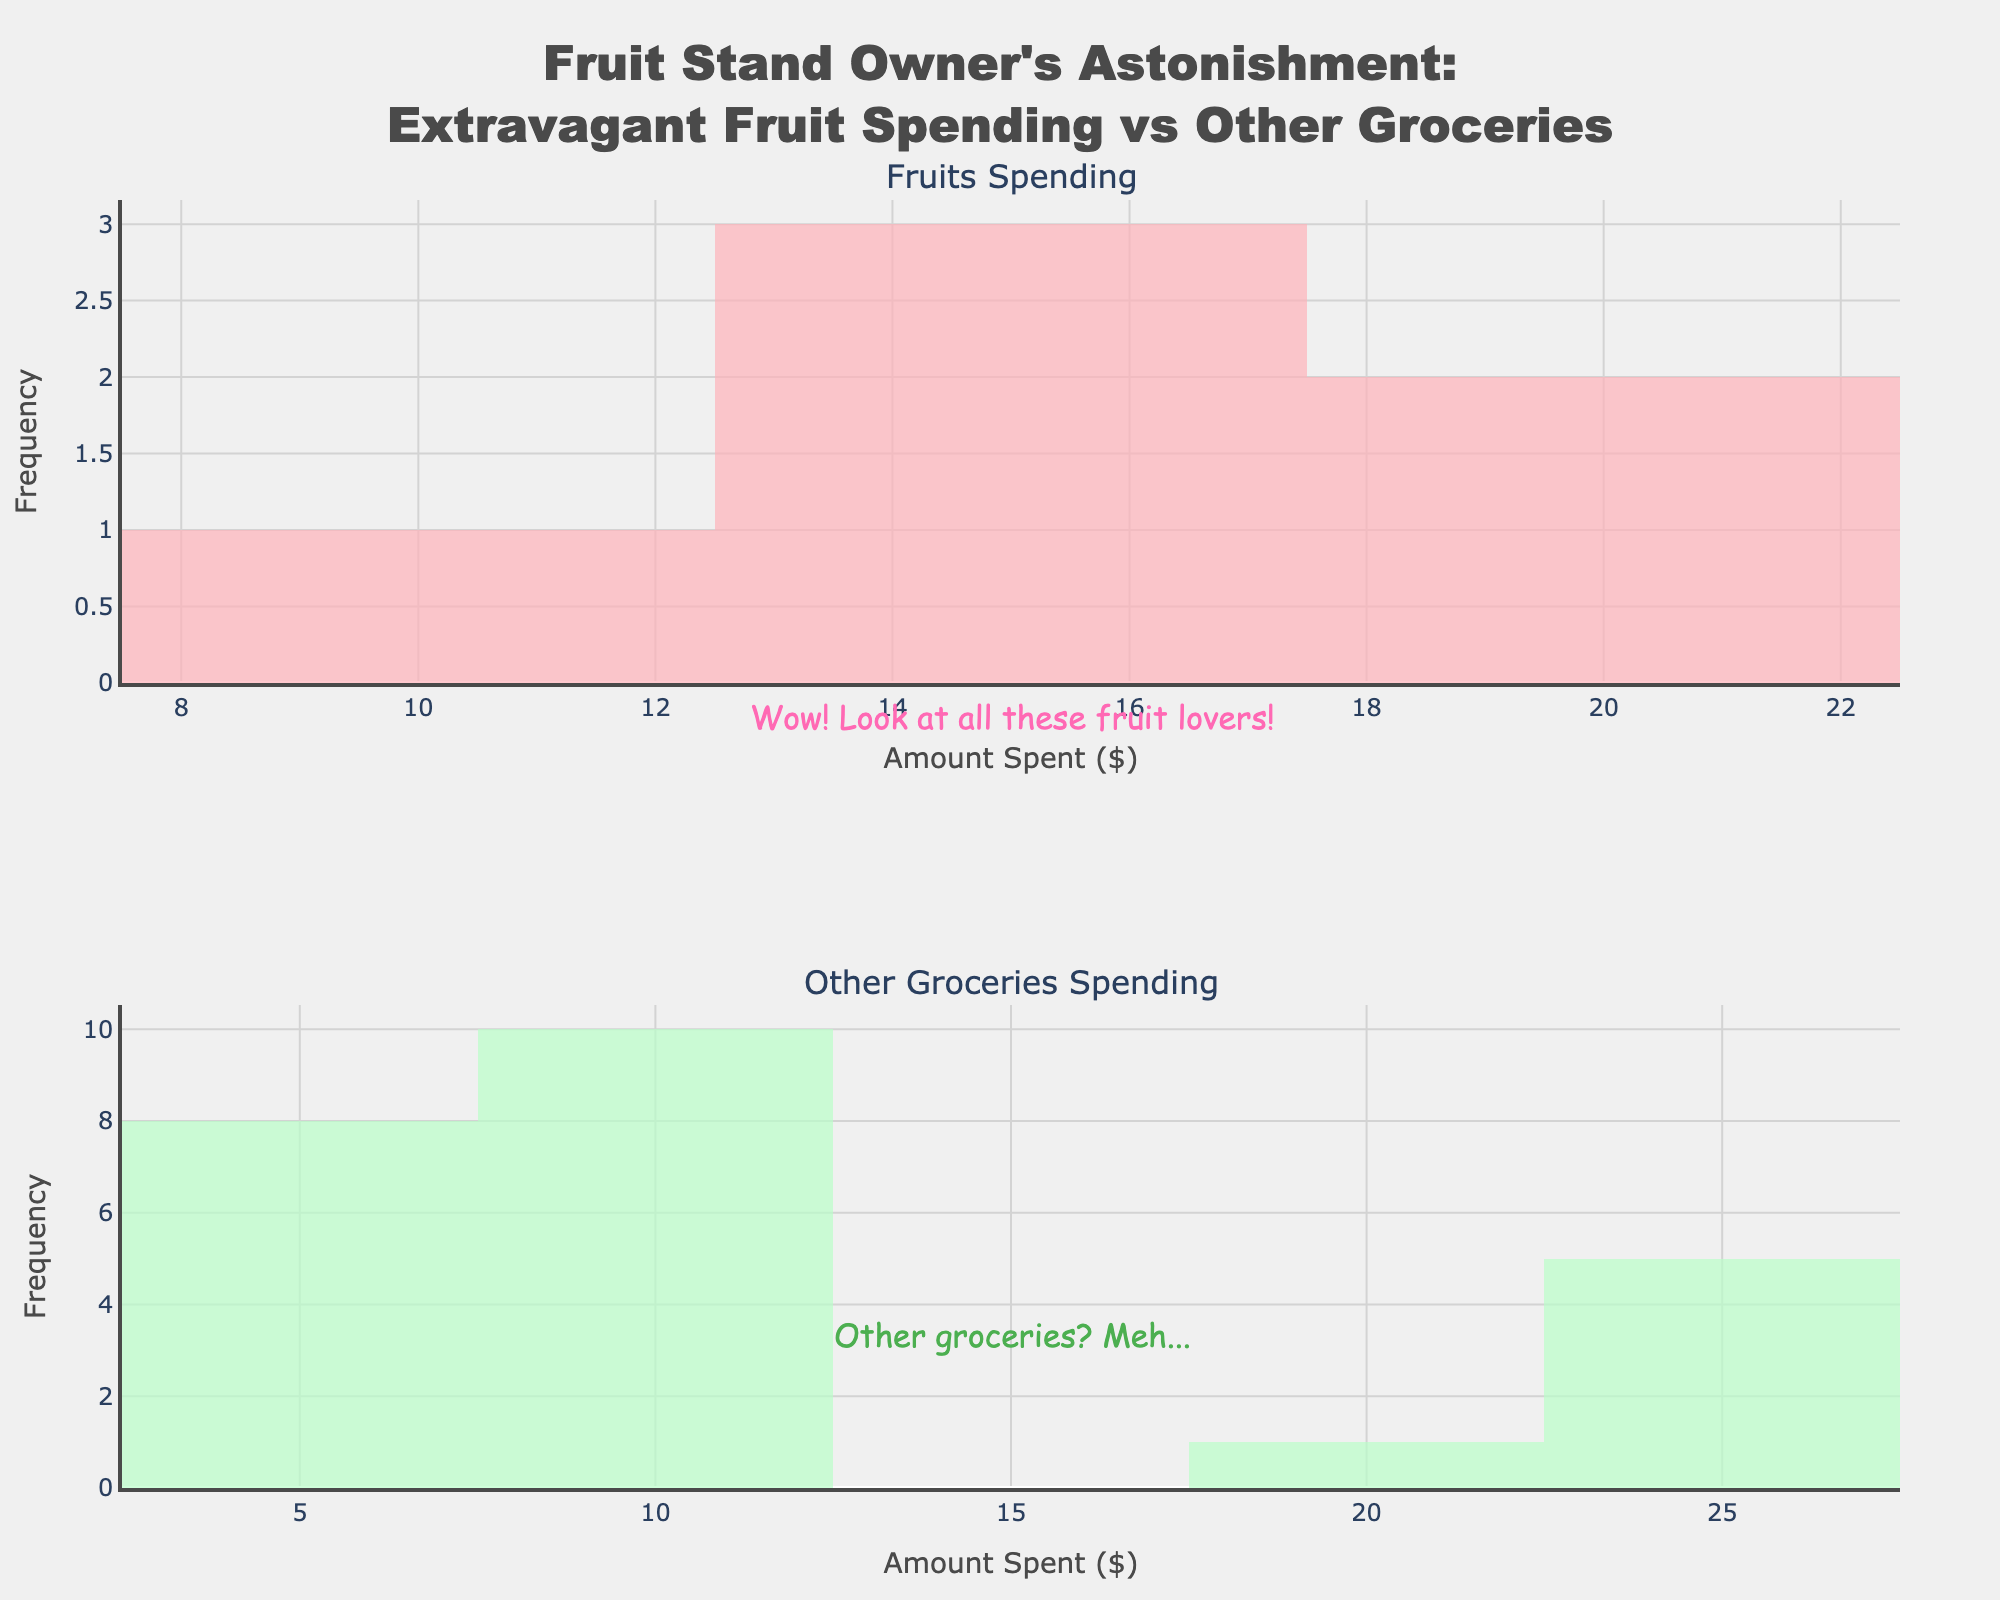What's the title of the figure? The title is located at the top of the figure. It provides a summary of what the figure represents. The title here is "Fruit Stand Owner's Astonishment: Extravagant Fruit Spending vs Other Groceries".
Answer: Fruit Stand Owner's Astonishment: Extravagant Fruit Spending vs Other Groceries What do the x-axes represent in both histograms? The x-axes in both histograms represent the amounts spent in dollars, as indicated by the x-axis labels "Amount Spent ($)".
Answer: Amount Spent ($) How many subplots are present in the figure? There are two subplots labeled "Fruits Spending" and "Other Groceries Spending". Each histogram represents a different category of spending.
Answer: Two What color represents "Fruits" spending in the figure? The color used for "Fruits" spending is a soft pink, visible in the upper histogram.
Answer: Pink What are the annotations in the figure, and where are they located? There are two annotations: "Wow! Look at all these fruit lovers!" located in the middle of the upper histogram and "Other groceries? Meh..." located in the lower part of the lower histogram.
Answer: "Wow! Look at all these fruit lovers!" and "Other groceries? Meh..." Which category shows higher overall spending, "Fruits" or "Other Groceries"? By comparing the left and right skew of the histograms, it's clear that "Fruits" has higher overall spending with more frequent occurrences of larger values compared to "Other Groceries".
Answer: Fruits How does the frequency of spending in the range of $5-$10 compare between "Fruits" and "Other Groceries"? "Other Groceries" spending in the $5-$10 range is higher in frequency compared to "Fruits," which is shown in the density of the histograms.
Answer: Higher in "Other Groceries" What is the most common spending amount for "Fruits"? The spending amount that appears most frequently for "Fruits" lies around $17, as shown by the peak of the histogram.
Answer: Around $17 Do either the "Fruits" or "Other Groceries" subplots show any spending amounts above $25? The "Other Groceries" subplot shows spending amounts that exceed $25, while "Fruits" does not.
Answer: Yes, "Other Groceries" Comparing the peaks, which subplot has a more varied spending range? The "Other Groceries" spending subplot has a more varied range of spending as its histogram is more spread out across different amounts compared to the narrow peak of "Fruits".
Answer: Other Groceries 